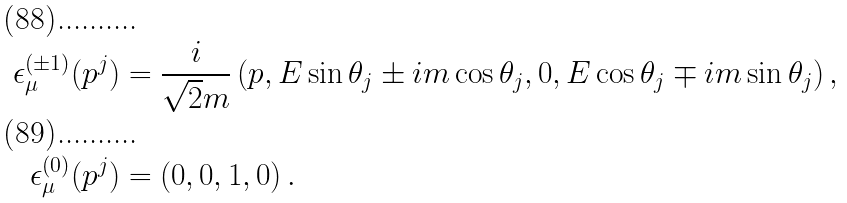Convert formula to latex. <formula><loc_0><loc_0><loc_500><loc_500>\epsilon ^ { ( \pm 1 ) } _ { \mu } ( p ^ { j } ) & = \frac { i } { \sqrt { 2 } m } \left ( p , E \sin \theta _ { j } \pm i m \cos \theta _ { j } , 0 , E \cos \theta _ { j } \mp i m \sin \theta _ { j } \right ) , \\ \epsilon ^ { ( 0 ) } _ { \mu } ( p ^ { j } ) & = \left ( 0 , 0 , 1 , 0 \right ) .</formula> 